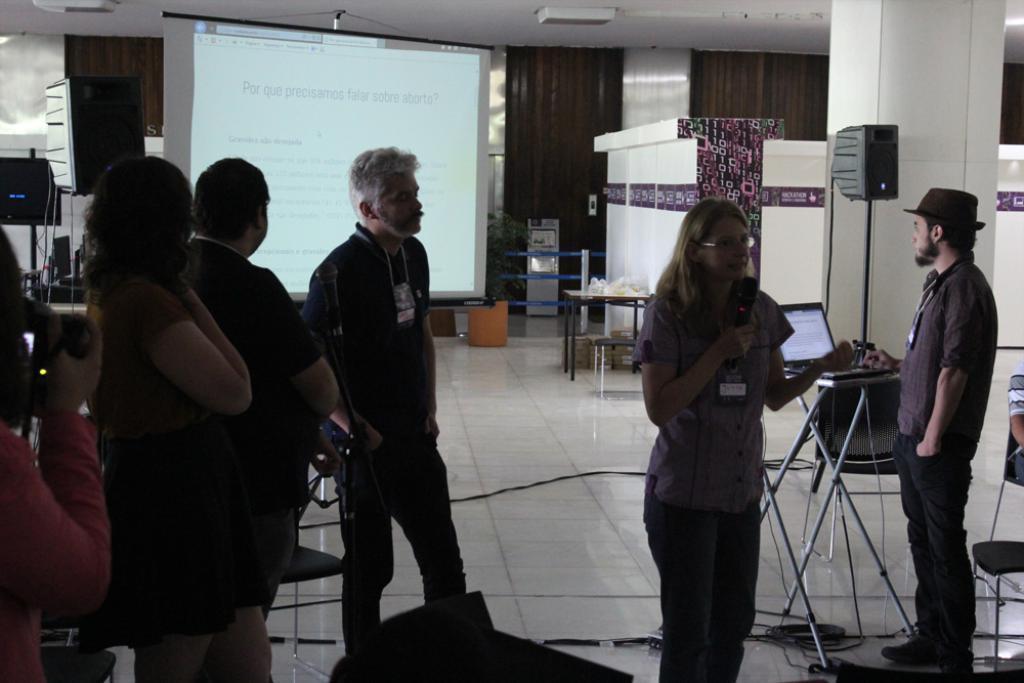How would you summarize this image in a sentence or two? In this picture I can see group of people standing, there is a person holding a mike, there are chairs, cables, there is a house plant, there is a projector screen, there is a laptop, table and there are some objects. 